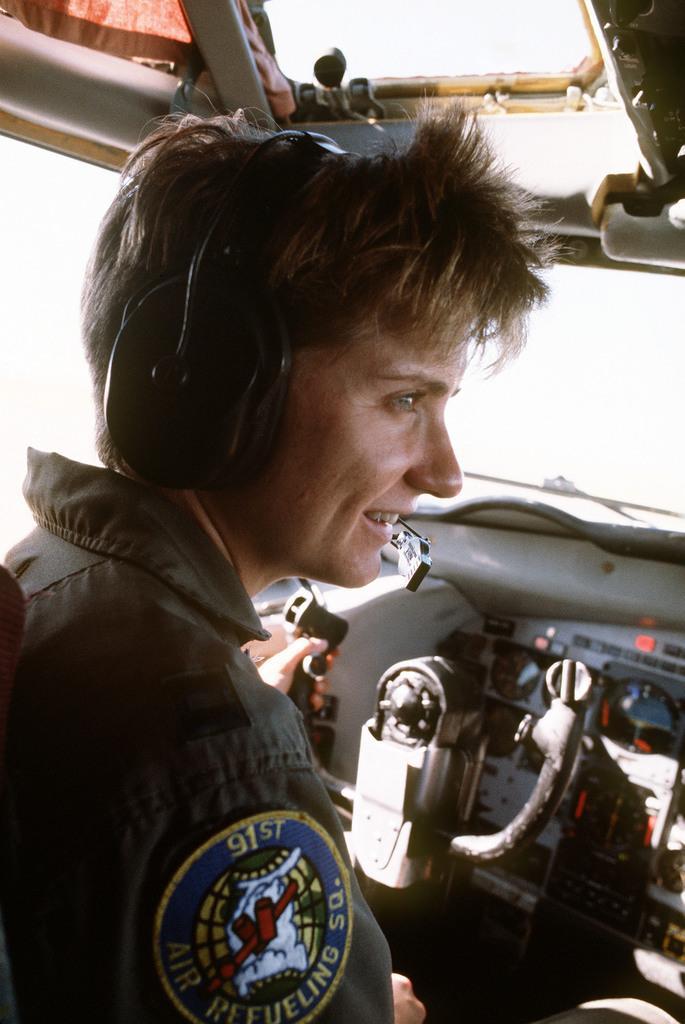Please provide a concise description of this image. A woman is in aircraft, she wore dress, headset and smiling. 